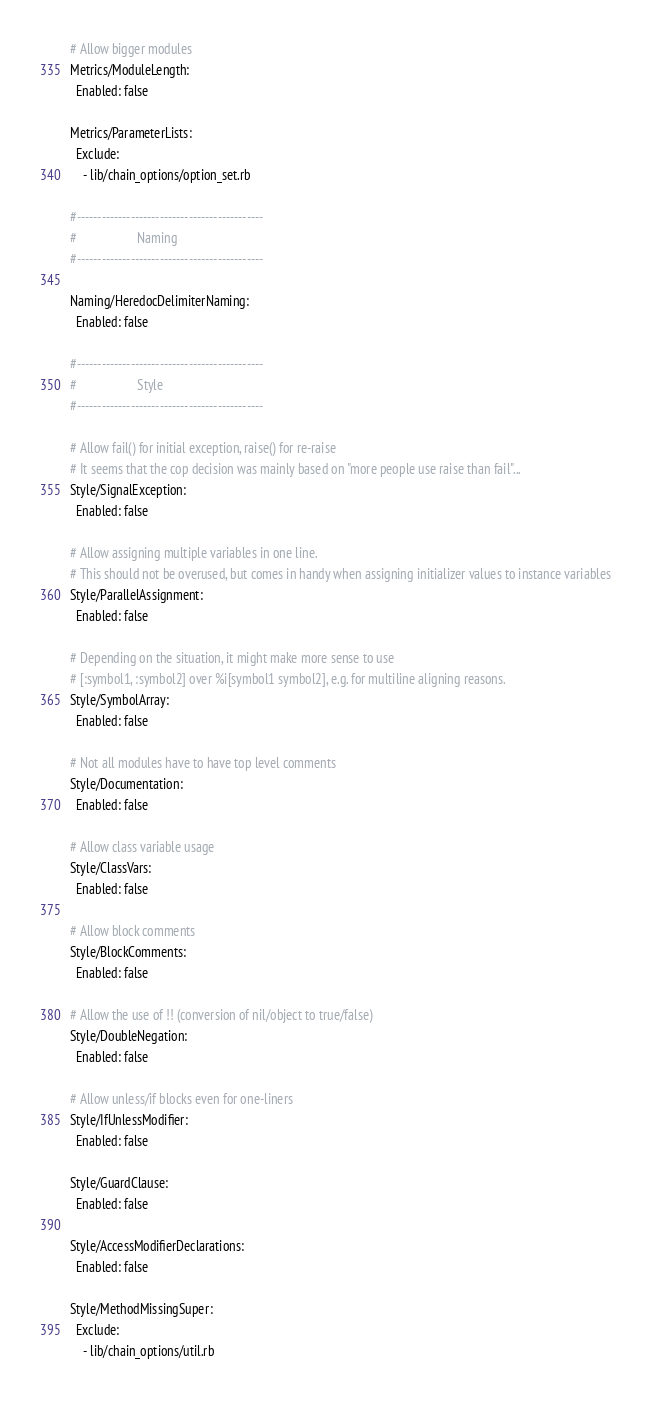<code> <loc_0><loc_0><loc_500><loc_500><_YAML_>
# Allow bigger modules
Metrics/ModuleLength:
  Enabled: false

Metrics/ParameterLists:
  Exclude:
    - lib/chain_options/option_set.rb

#---------------------------------------------
#                   Naming
#---------------------------------------------

Naming/HeredocDelimiterNaming:
  Enabled: false

#---------------------------------------------
#                   Style
#---------------------------------------------

# Allow fail() for initial exception, raise() for re-raise
# It seems that the cop decision was mainly based on "more people use raise than fail"...
Style/SignalException:
  Enabled: false

# Allow assigning multiple variables in one line.
# This should not be overused, but comes in handy when assigning initializer values to instance variables
Style/ParallelAssignment:
  Enabled: false

# Depending on the situation, it might make more sense to use
# [:symbol1, :symbol2] over %i[symbol1 symbol2], e.g. for multiline aligning reasons.
Style/SymbolArray:
  Enabled: false

# Not all modules have to have top level comments
Style/Documentation:
  Enabled: false

# Allow class variable usage
Style/ClassVars:
  Enabled: false

# Allow block comments
Style/BlockComments:
  Enabled: false

# Allow the use of !! (conversion of nil/object to true/false)
Style/DoubleNegation:
  Enabled: false

# Allow unless/if blocks even for one-liners
Style/IfUnlessModifier:
  Enabled: false

Style/GuardClause:
  Enabled: false

Style/AccessModifierDeclarations:
  Enabled: false

Style/MethodMissingSuper:
  Exclude:
    - lib/chain_options/util.rb
</code> 